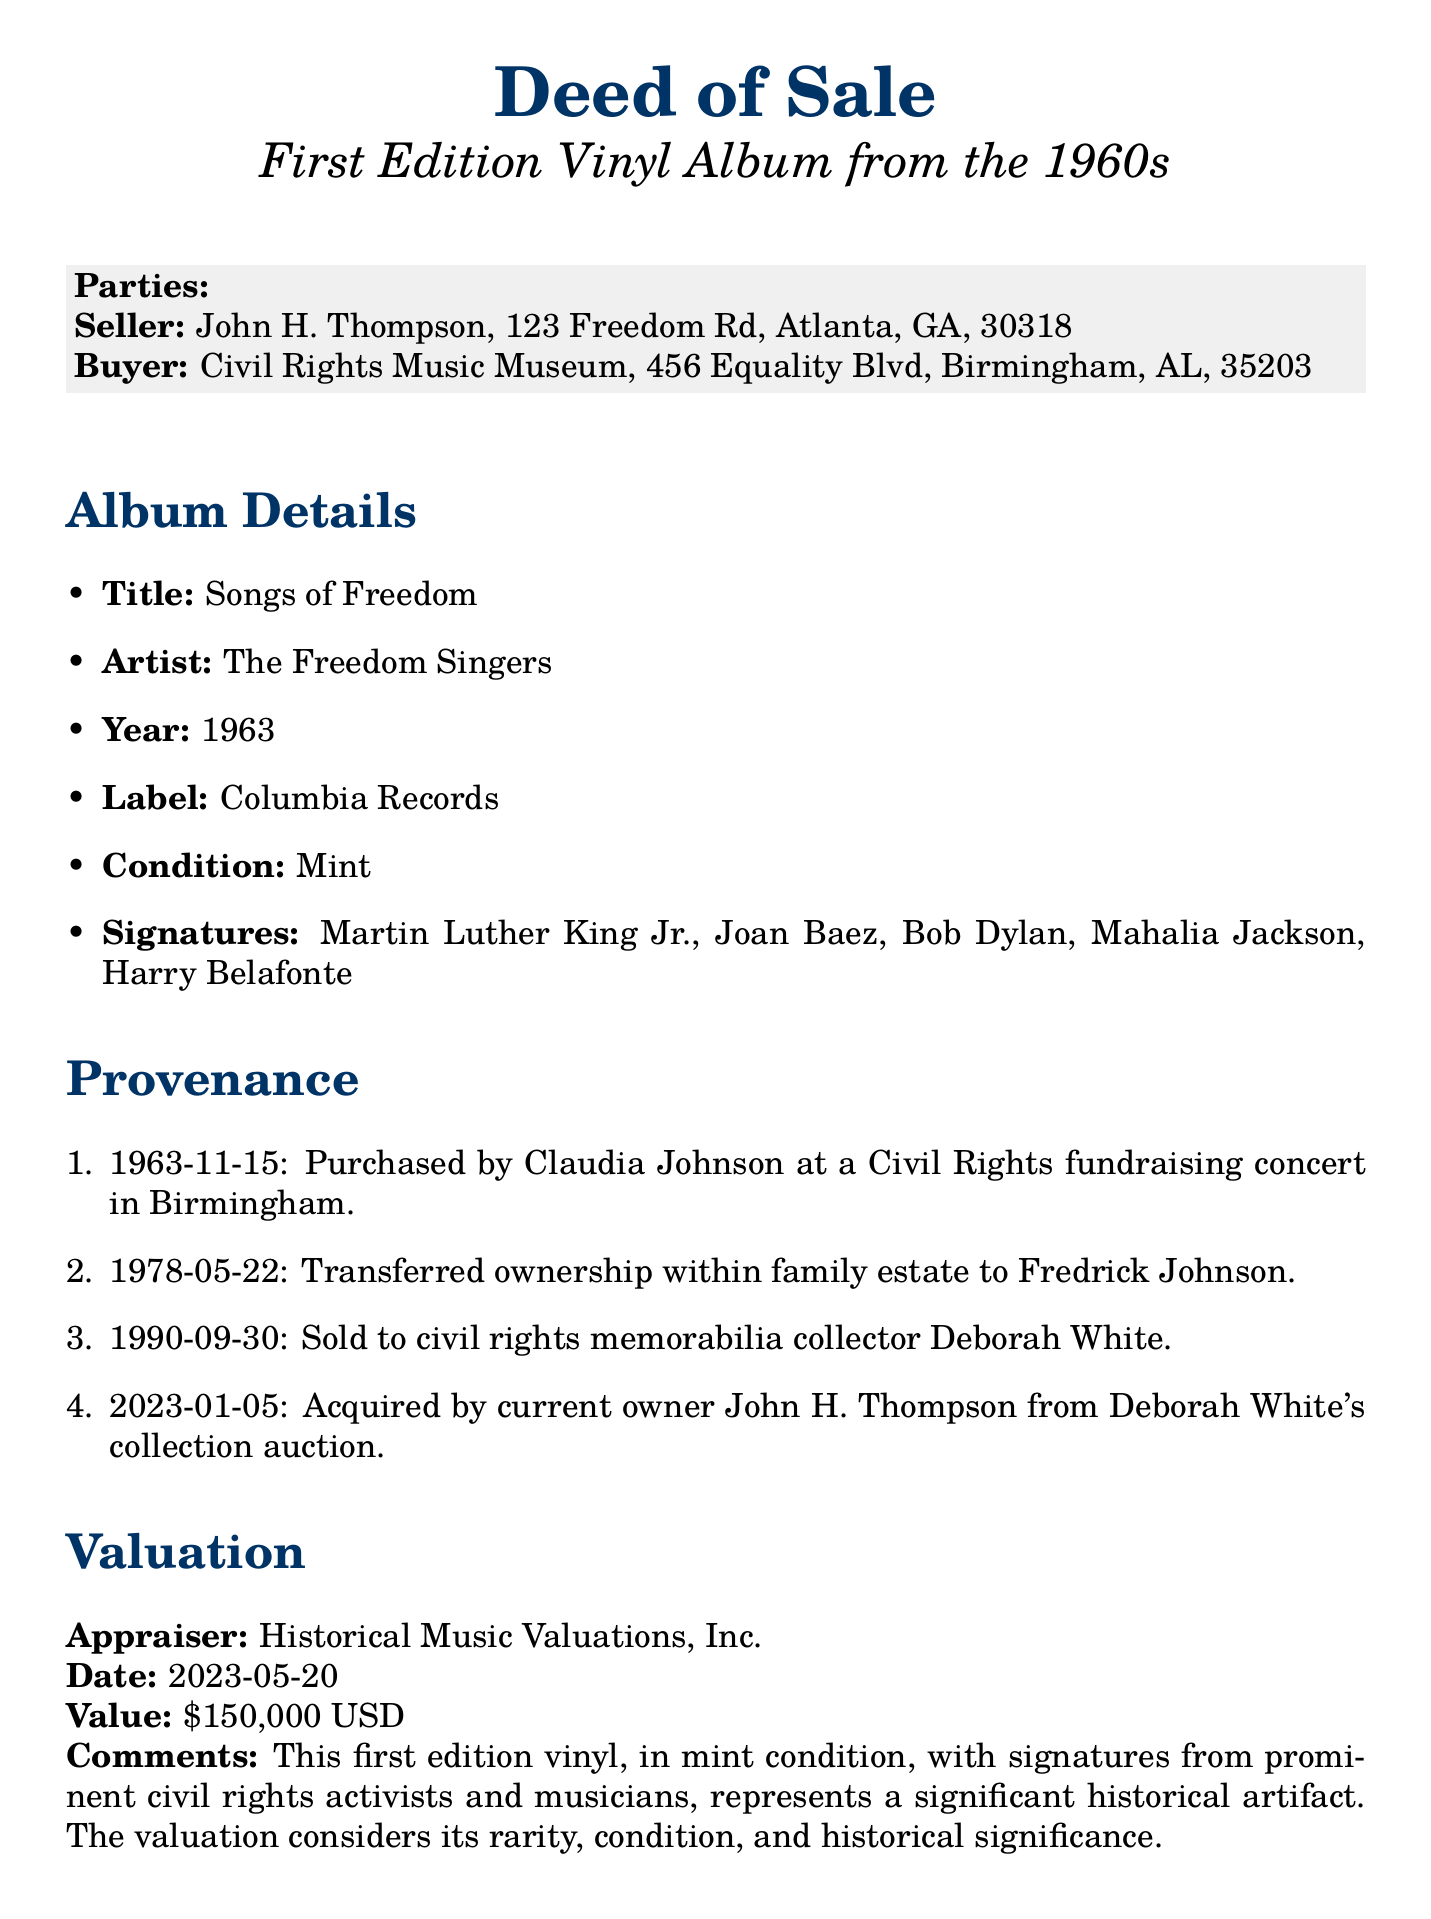What is the title of the album? The title of the album is listed in the document under album details as "Songs of Freedom."
Answer: Songs of Freedom Who was the buyer of the album? The buyer is specified at the beginning of the document as "Civil Rights Music Museum."
Answer: Civil Rights Music Museum What year was the album released? The year of release for the album is noted in the album details section as 1963.
Answer: 1963 Who signed the album? The signatures are mentioned in the album details, including Martin Luther King Jr., Joan Baez, Bob Dylan, Mahalia Jackson, and Harry Belafonte.
Answer: Martin Luther King Jr., Joan Baez, Bob Dylan, Mahalia Jackson, Harry Belafonte What is the appraised value? The valuation section of the document states the appraised value as $150,000 USD.
Answer: $150,000 USD When was the seller's signature dated? The seller's signature date can be found at the end of the document and is listed as 2023-10-15.
Answer: 2023-10-15 What condition is the album in? The condition of the album is specified in the album details as "Mint."
Answer: Mint When was the album first purchased? The provenance section indicates the album was first purchased on 1963-11-15.
Answer: 1963-11-15 Who appraised the album? The appraiser mentioned in the valuation section is "Historical Music Valuations, Inc."
Answer: Historical Music Valuations, Inc 